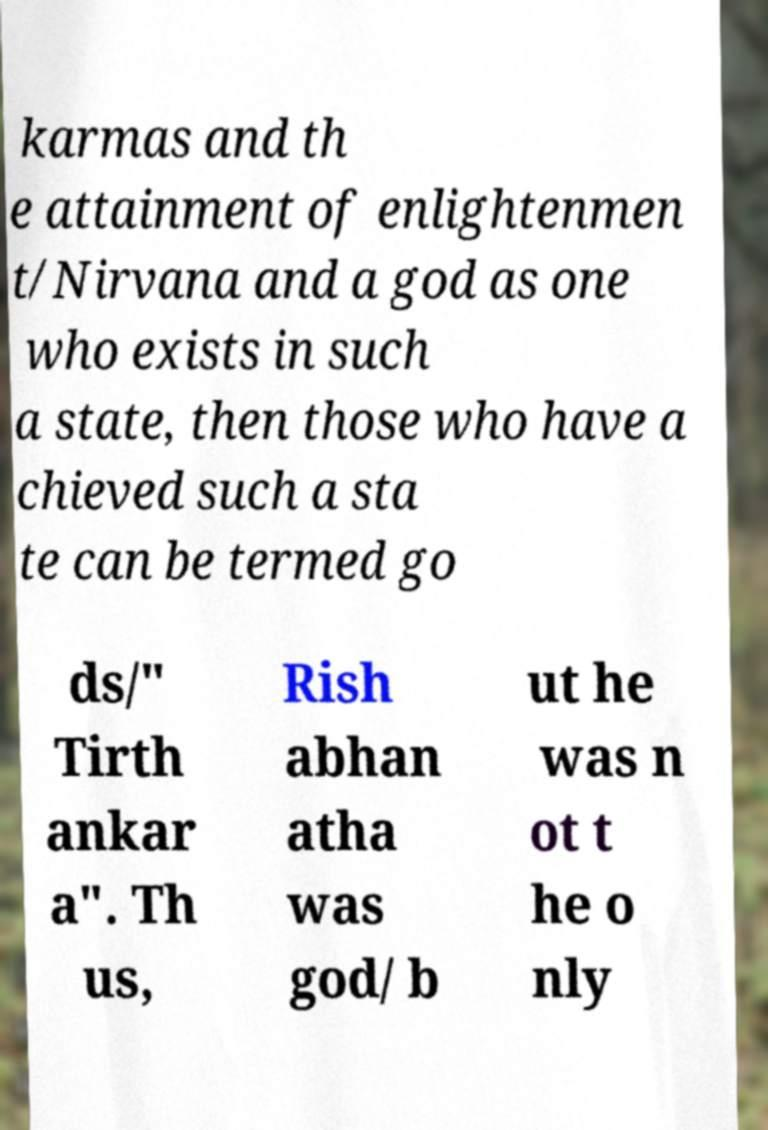Could you assist in decoding the text presented in this image and type it out clearly? karmas and th e attainment of enlightenmen t/Nirvana and a god as one who exists in such a state, then those who have a chieved such a sta te can be termed go ds/" Tirth ankar a". Th us, Rish abhan atha was god/ b ut he was n ot t he o nly 